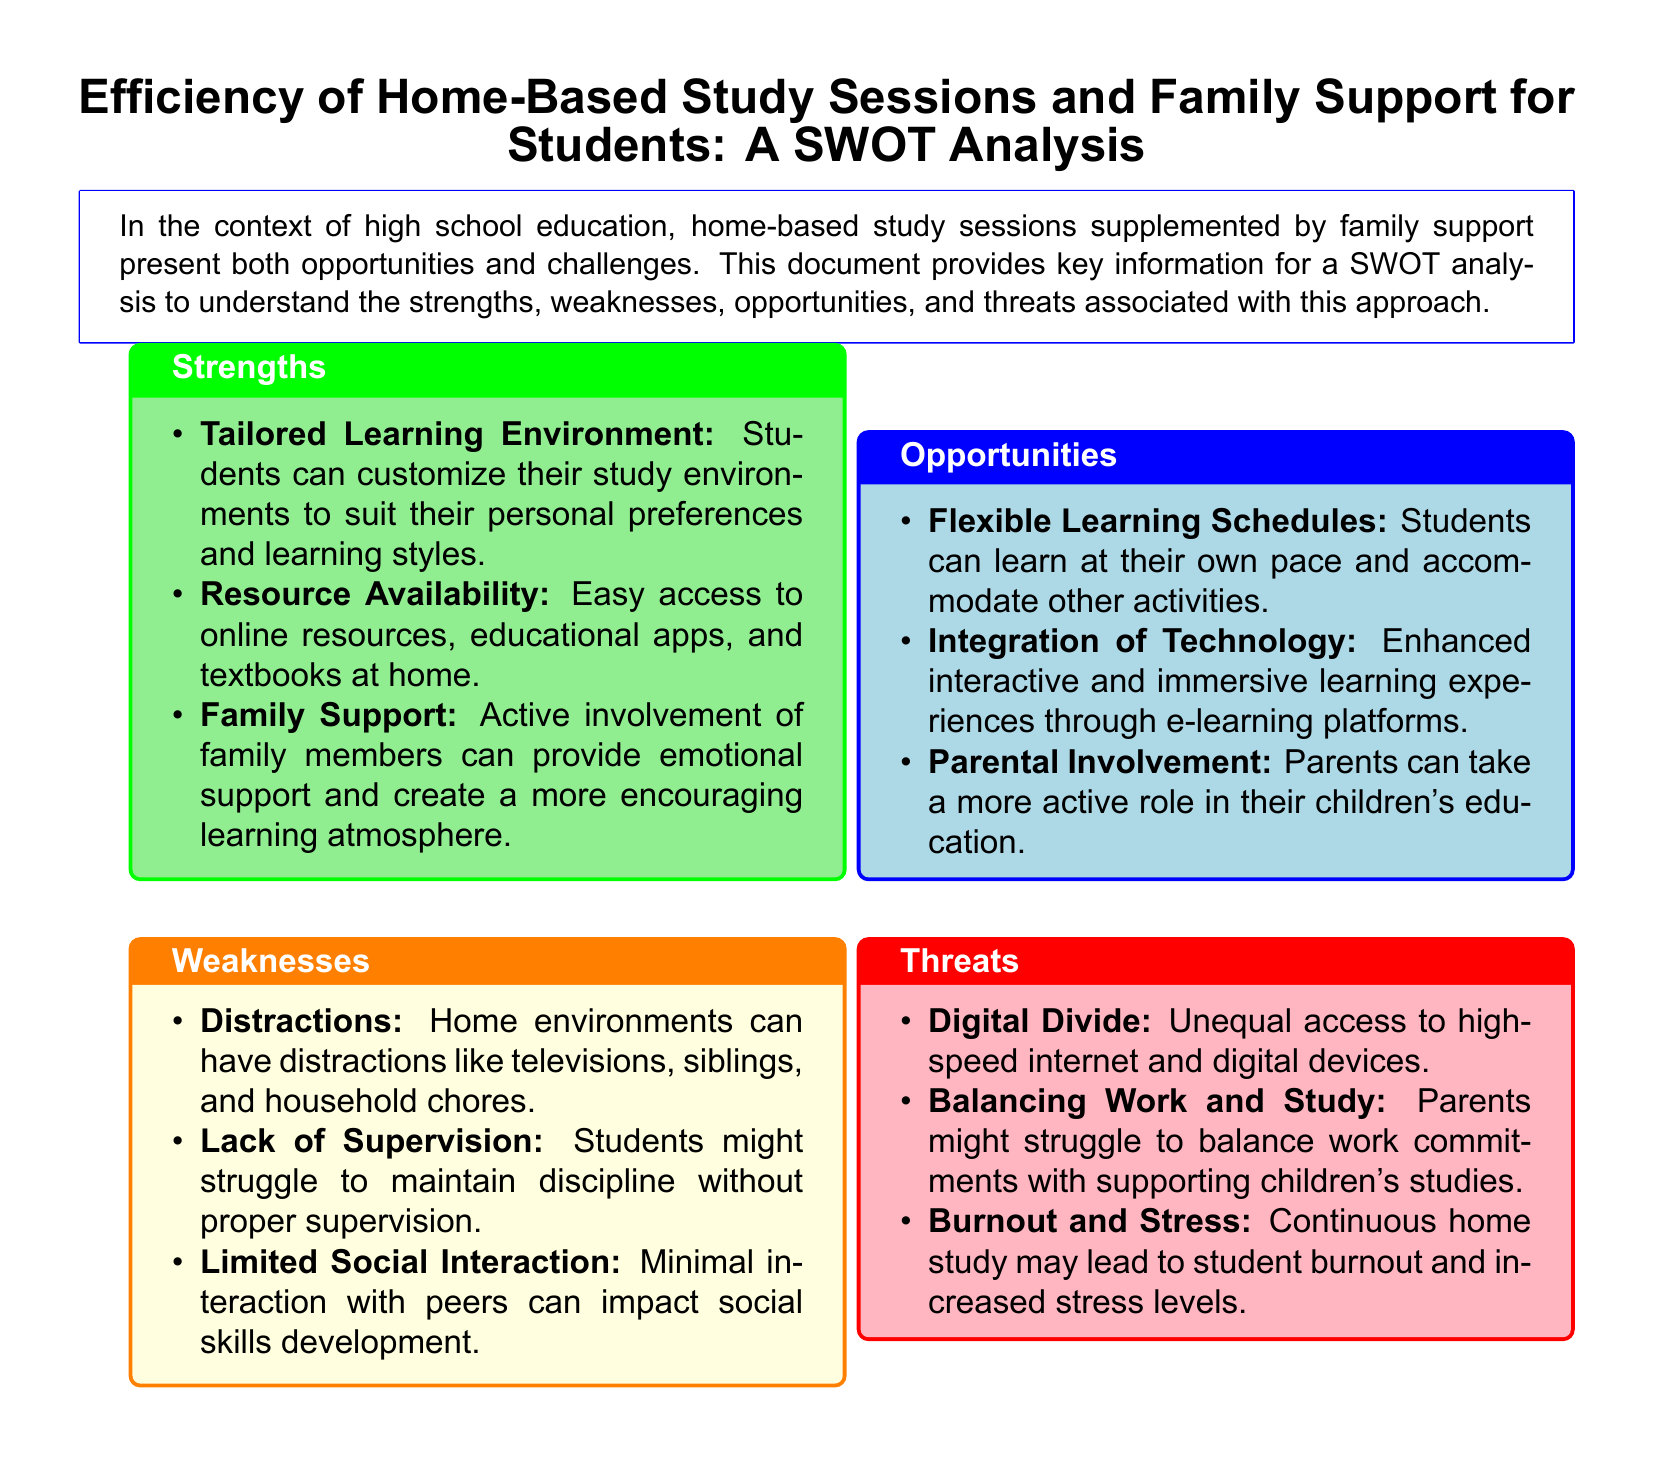What is the title of the document? The title of the document is presented at the top, highlighting the main focus of the analysis.
Answer: Efficiency of Home-Based Study Sessions and Family Support for Students: A SWOT Analysis What color represents strengths in the document? The color used for the strengths section is specified in the document, distinguishing it from other sections.
Answer: Light green How many weaknesses are listed in the document? The document provides a specific number of weaknesses in bullet points, which can be counted.
Answer: Three What is one opportunity mentioned in the document? One of the opportunities identified in the analysis is highlighted as a bullet point, showcasing a positive aspect.
Answer: Flexible Learning Schedules What is a threat to home-based study sessions? The document specifies various threats to this mode of learning, indicating potential challenges faced.
Answer: Digital Divide Why is family support considered a strength? Family support is highlighted as a strength due to its role in enhancing the learning atmosphere for students.
Answer: Emotional support What does the document suggest is a factor impacting social skills development? The document outlines a specific weakness regarding social interactions, which is crucial for social skill development.
Answer: Limited Social Interaction What advantage does technology integration provide? The document mentions a particular benefit of using technology in the learning process.
Answer: Enhanced interactive and immersive learning experiences What does the analysis aim to understand? The purpose of the SWOT analysis is stated in the introductory part of the document, which encompasses its goals.
Answer: Strengths, weaknesses, opportunities, and threats 